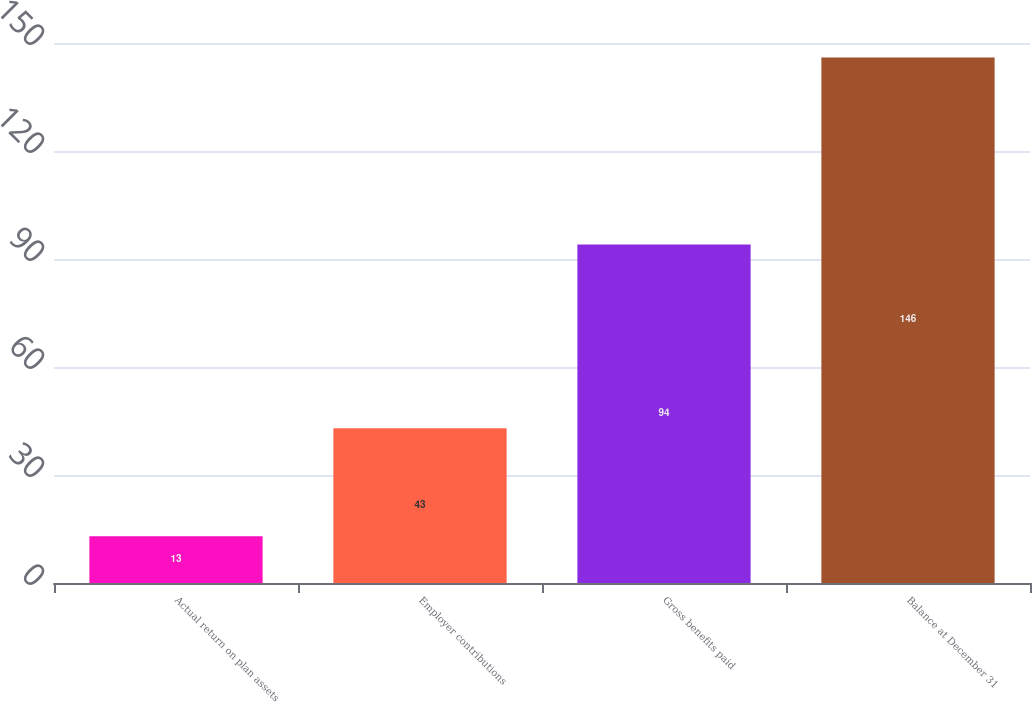Convert chart. <chart><loc_0><loc_0><loc_500><loc_500><bar_chart><fcel>Actual return on plan assets<fcel>Employer contributions<fcel>Gross benefits paid<fcel>Balance at December 31<nl><fcel>13<fcel>43<fcel>94<fcel>146<nl></chart> 